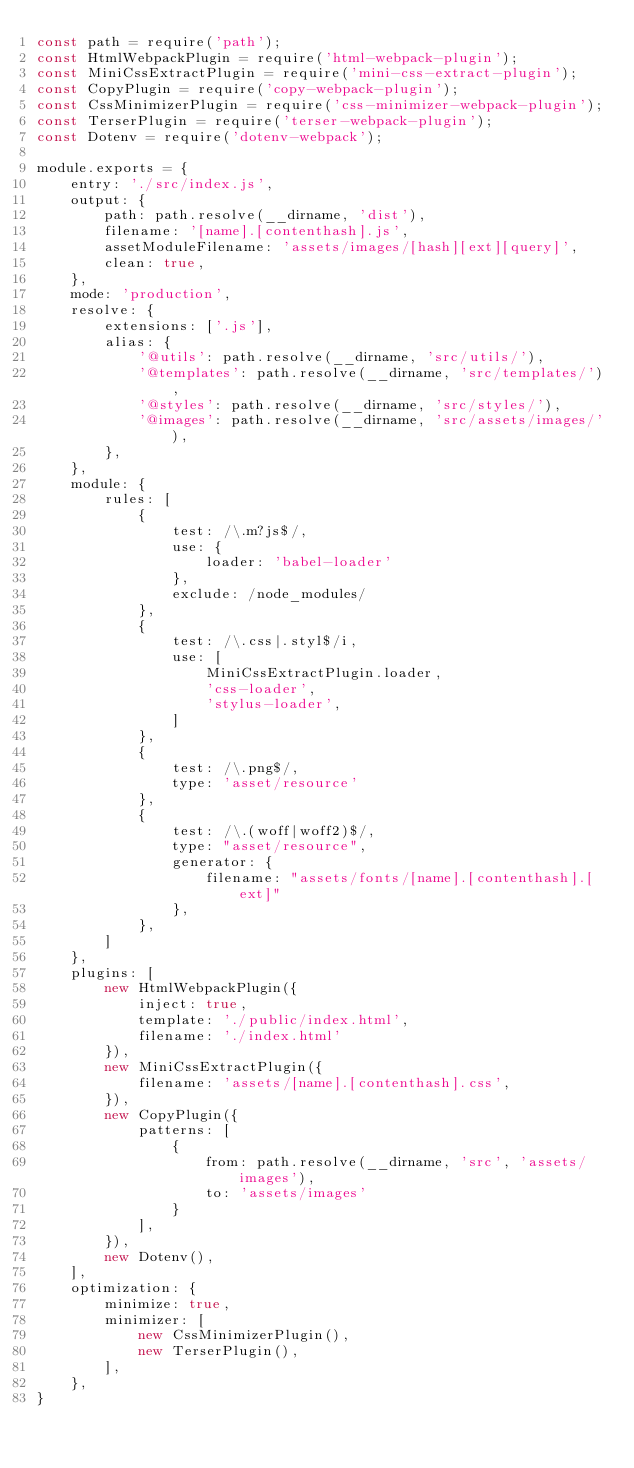<code> <loc_0><loc_0><loc_500><loc_500><_JavaScript_>const path = require('path');
const HtmlWebpackPlugin = require('html-webpack-plugin');
const MiniCssExtractPlugin = require('mini-css-extract-plugin');
const CopyPlugin = require('copy-webpack-plugin');
const CssMinimizerPlugin = require('css-minimizer-webpack-plugin');
const TerserPlugin = require('terser-webpack-plugin');
const Dotenv = require('dotenv-webpack');

module.exports = {
    entry: './src/index.js',
    output: {
        path: path.resolve(__dirname, 'dist'),
        filename: '[name].[contenthash].js',
        assetModuleFilename: 'assets/images/[hash][ext][query]',
        clean: true,
    },
    mode: 'production',
    resolve: {
        extensions: ['.js'],
        alias: {
            '@utils': path.resolve(__dirname, 'src/utils/'),
            '@templates': path.resolve(__dirname, 'src/templates/'),
            '@styles': path.resolve(__dirname, 'src/styles/'),
            '@images': path.resolve(__dirname, 'src/assets/images/'),
        },
    },
    module: {
        rules: [
            {
                test: /\.m?js$/,
                use: {
                    loader: 'babel-loader'
                },
                exclude: /node_modules/
            },
            {
                test: /\.css|.styl$/i,
                use: [
                    MiniCssExtractPlugin.loader,
                    'css-loader',
                    'stylus-loader',
                ]
            },
            {
                test: /\.png$/,
                type: 'asset/resource'
            },
            {
                test: /\.(woff|woff2)$/,
                type: "asset/resource",
                generator: {
                    filename: "assets/fonts/[name].[contenthash].[ext]"
                },
            },
        ]
    },
    plugins: [
        new HtmlWebpackPlugin({
            inject: true,
            template: './public/index.html',
            filename: './index.html'
        }),
        new MiniCssExtractPlugin({
            filename: 'assets/[name].[contenthash].css',
        }),
        new CopyPlugin({
            patterns: [
                {
                    from: path.resolve(__dirname, 'src', 'assets/images'),
                    to: 'assets/images'
                }
            ],
        }),
        new Dotenv(),
    ],
    optimization: {
        minimize: true,
        minimizer: [
            new CssMinimizerPlugin(),
            new TerserPlugin(),
        ],
    },
}</code> 